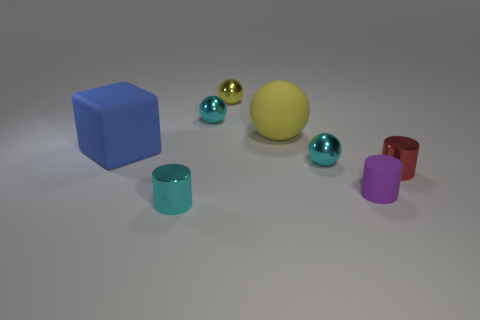There is a yellow matte object that is the same shape as the yellow metallic object; what size is it?
Give a very brief answer. Large. Is there anything else that has the same size as the red object?
Provide a short and direct response. Yes. The cyan object that is in front of the shiny cylinder that is behind the tiny cyan metallic thing that is in front of the red metallic cylinder is made of what material?
Make the answer very short. Metal. Are there more cyan balls in front of the small yellow ball than tiny rubber objects that are in front of the cyan cylinder?
Keep it short and to the point. Yes. Does the red metal object have the same size as the matte cylinder?
Offer a very short reply. Yes. There is a rubber thing that is the same shape as the small red metallic object; what is its color?
Offer a terse response. Purple. How many large rubber cubes have the same color as the big matte sphere?
Your answer should be very brief. 0. Are there more tiny objects that are right of the yellow matte object than yellow objects?
Give a very brief answer. Yes. What color is the shiny cylinder to the right of the cyan shiny ball that is left of the yellow matte ball?
Offer a terse response. Red. What number of objects are small metallic cylinders that are on the right side of the cyan cylinder or tiny objects behind the matte cylinder?
Your answer should be very brief. 4. 